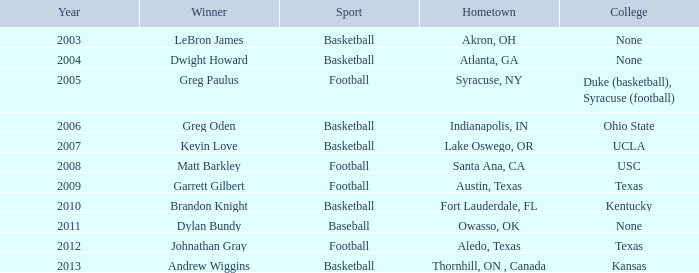What is Hometown, when Sport is "Basketball", and when Winner is "Dwight Howard"? Atlanta, GA. 